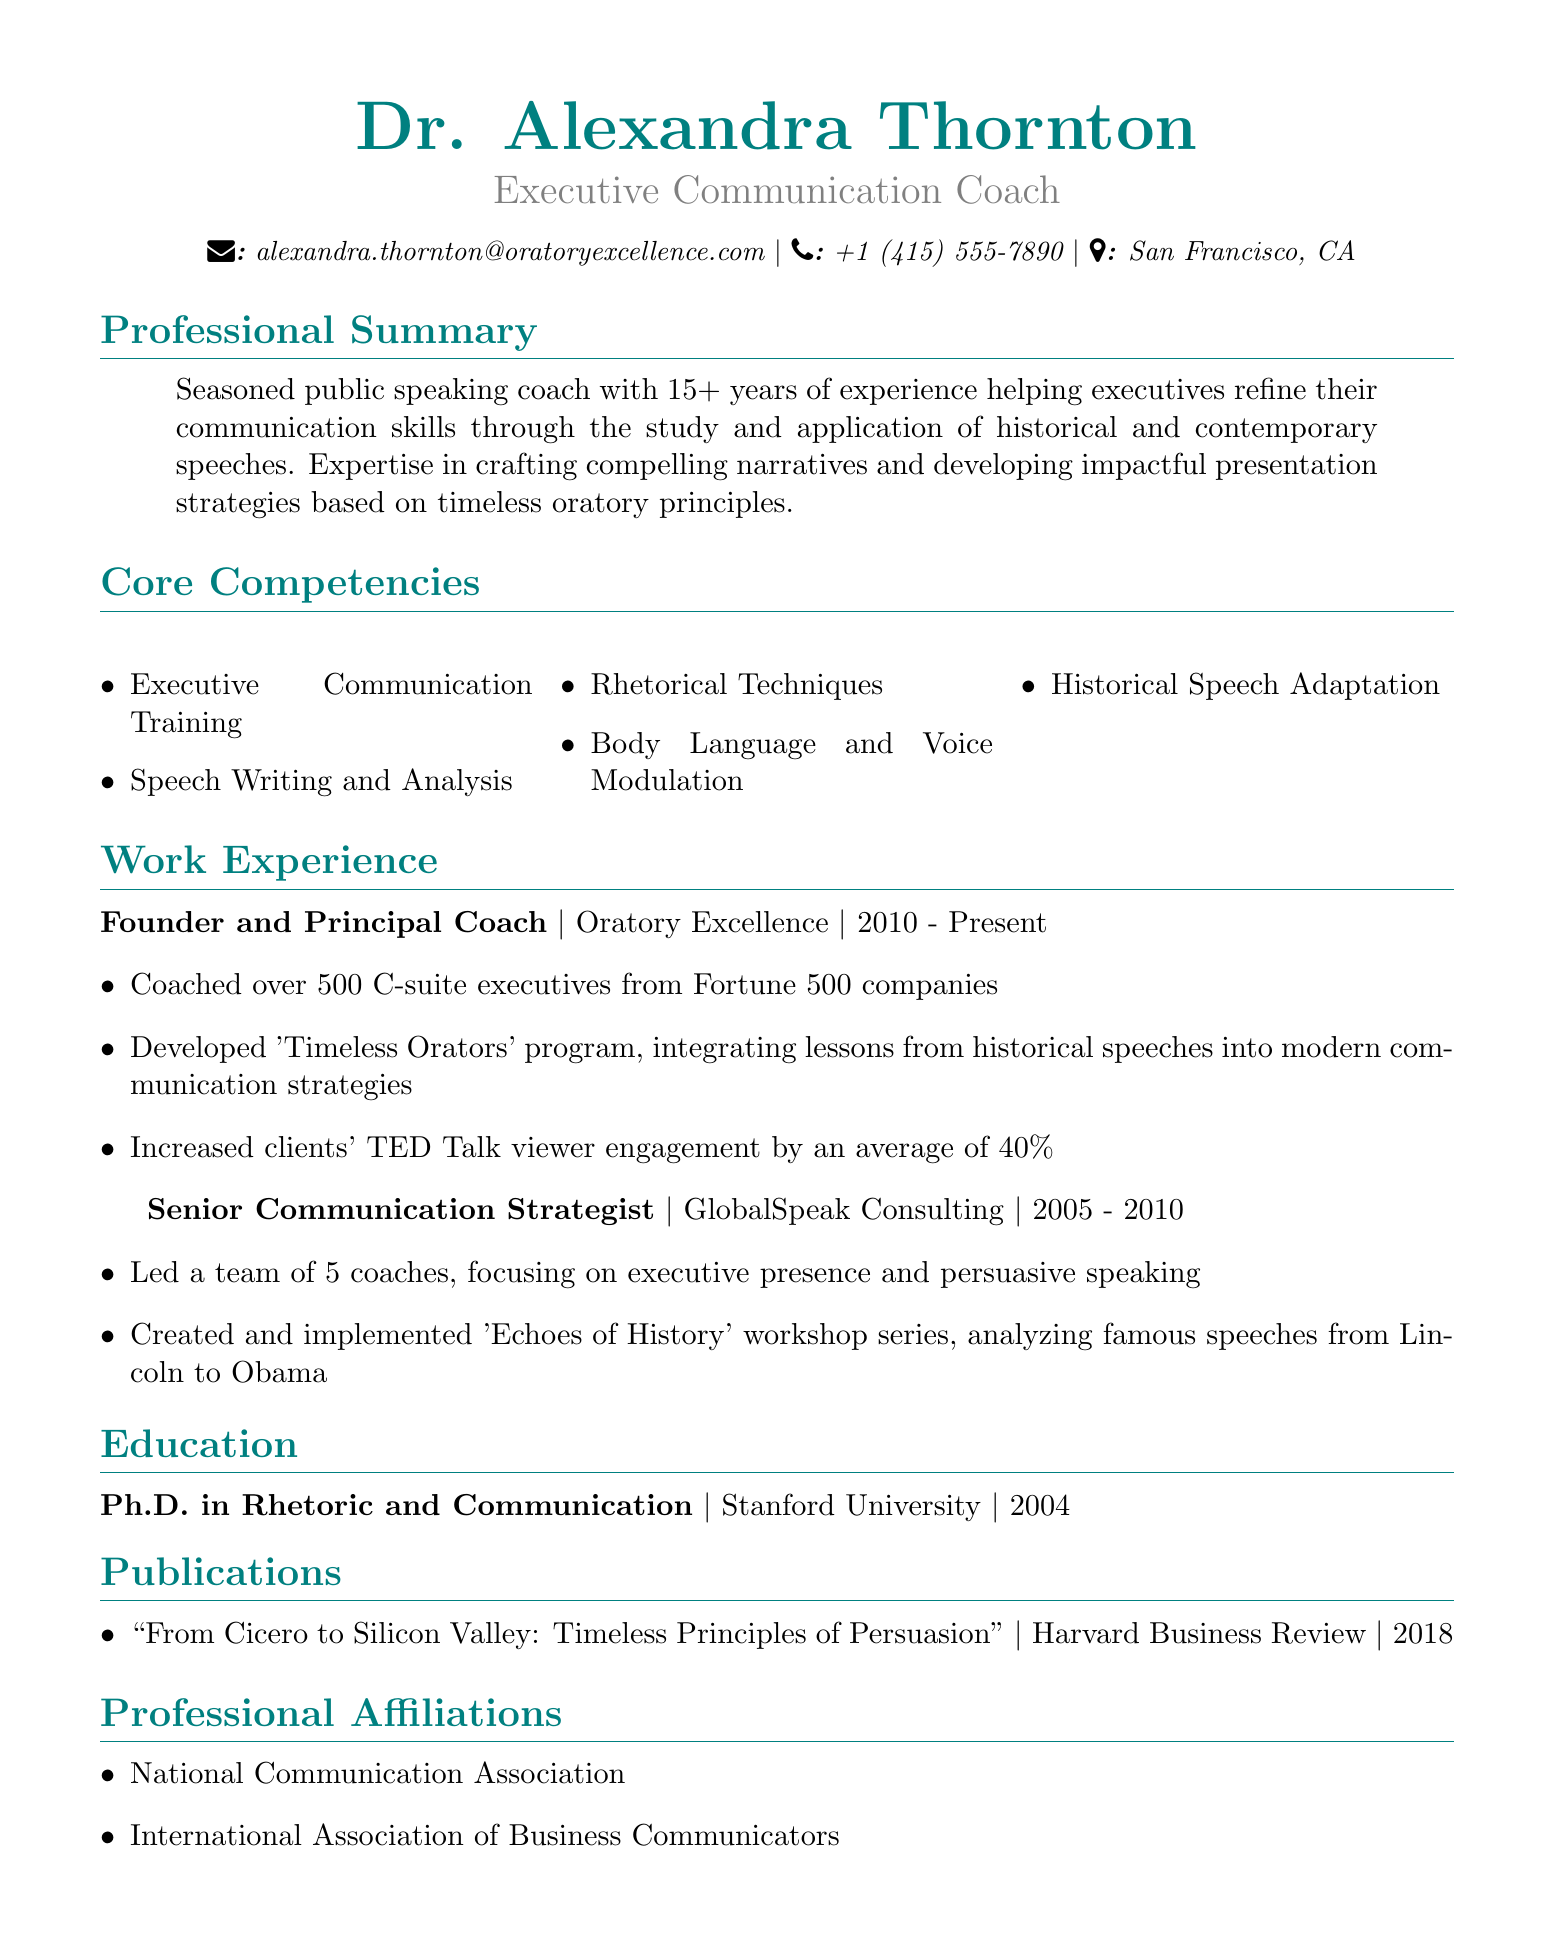What is the name of the communication coach? The name of the communication coach is found in the personal information section of the document.
Answer: Dr. Alexandra Thornton How many years of experience does Dr. Thornton have? The professional summary provides information about the number of years of experience the coach has.
Answer: 15+ What is the title of the publication? The publication section contains the title of the document published by Dr. Thornton.
Answer: "From Cicero to Silicon Valley: Timeless Principles of Persuasion" Which company is Dr. Thornton currently associated with? The work experience section lists the current position and company where Dr. Thornton is employed.
Answer: Oratory Excellence What was the name of the workshop series created by Dr. Thornton? The achievements listed under the work experience section mention the workshop series that was created.
Answer: Echoes of History In what year did Dr. Thornton complete her Ph.D.? The education section of the document indicates the year Dr. Thornton earned her Ph.D.
Answer: 2004 How many coaches did Dr. Thornton lead at GlobalSpeak Consulting? The work experience section reveals the size of the team Dr. Thornton managed during her tenure.
Answer: 5 What is one of the core competencies listed in the document? The core competencies section contains specific skills that Dr. Thornton possesses as a communication coach.
Answer: Executive Communication Training 